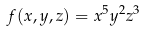Convert formula to latex. <formula><loc_0><loc_0><loc_500><loc_500>f ( x , y , z ) = x ^ { 5 } y ^ { 2 } z ^ { 3 }</formula> 